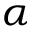Convert formula to latex. <formula><loc_0><loc_0><loc_500><loc_500>\alpha</formula> 